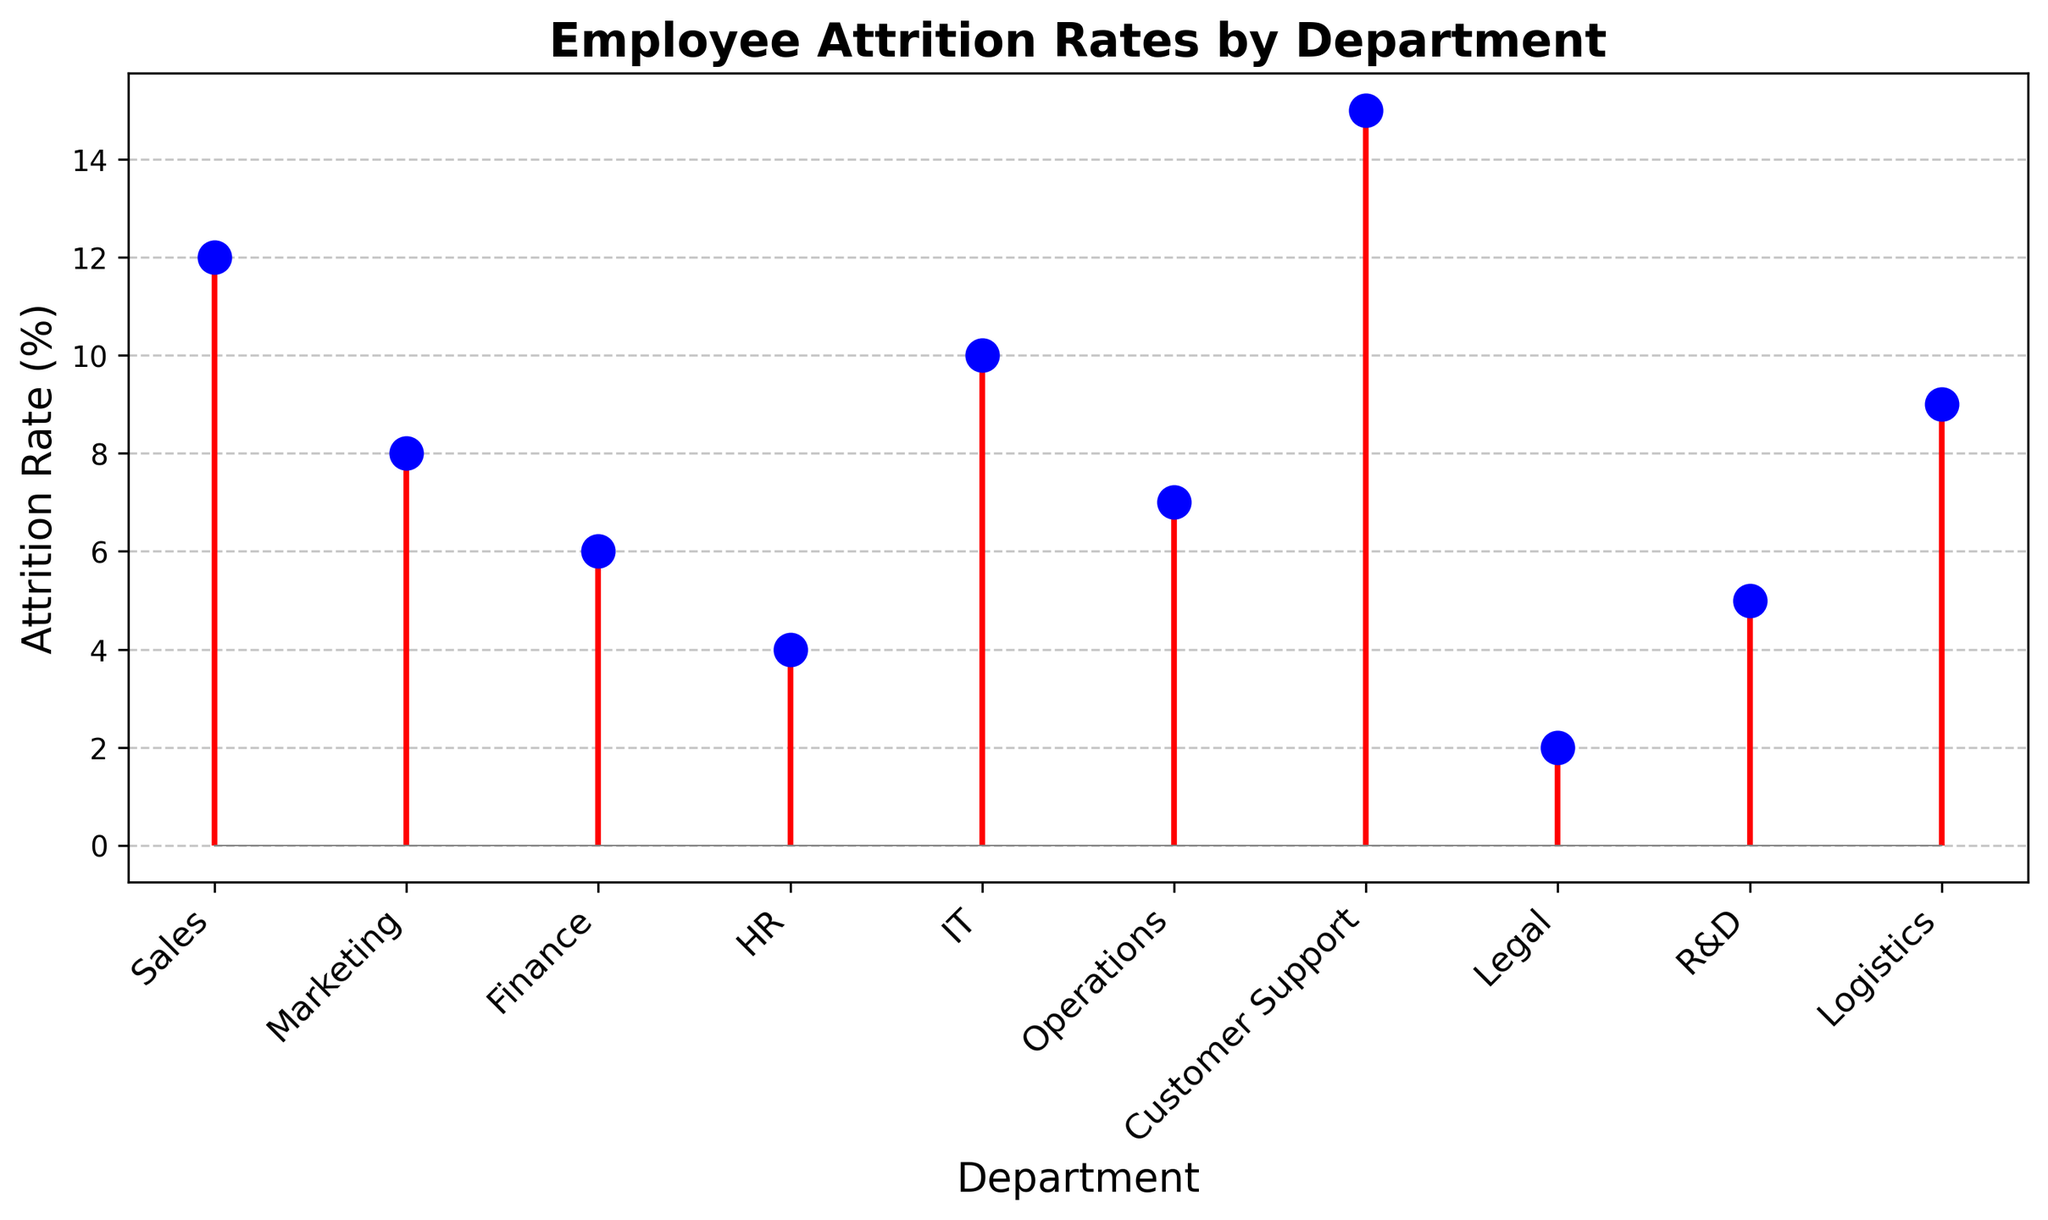What department has the highest attrition rate? By looking at the figure, identify the department with the tallest stem line, which is the blue line with the highest red line.
Answer: Customer Support Which department has an attrition rate lower than 5%? Locate the stems that do not reach the 5% mark on the y-axis. The Legal and HR departments have these shorter stems.
Answer: Legal, HR What's the difference in attrition rates between the Sales and IT departments? Identify the y-values for both the Sales and IT departments, which are 12% and 10% respectively. Subtract the IT attrition rate from the Sales attrition rate: 12 - 10 = 2.
Answer: 2% How many departments have an attrition rate greater than 8%? Count the number of stems that go above the 8% mark. The answer is four: Sales, IT, Customer Support, and Logistics.
Answer: 4 What's the median attrition rate of the departments? List all the attrition rates in ascending order: 2, 4, 5, 6, 7, 8, 9, 10, 12, 15. Since there are 10 values, the median is the average of the 5th and 6th values. (7+8)/2 = 7.5.
Answer: 7.5% Which department has the second lowest attrition rate? Arrange the attrition rates in ascending order: Legal (2), HR (4), R&D (5), and so on. The second department on the list is HR.
Answer: HR What is the average attrition rate of departments with rates lower than 10%? Identify the departments with rates under 10%: Legal (2), HR (4), R&D (5), Finance (6), Operations (7), and Marketing (8). Calculate the average: (2 + 4 + 5 +6 + 7 + 8)/6 ≈ 5.33.
Answer: 5.33% Compare the attrition rates between the Finance and Marketing departments. Which one is higher? Locate the y-values for both the Finance (6%) and Marketing (8%) departments. Marketing has a higher attrition rate.
Answer: Marketing Which department has a stem with the third tallest height? Rank the stems by their heights to find that the Sales, Customer Support, and then IT departments have the tallest stems in that order.
Answer: IT What is the combined attrition rate for the HR, Legal, and R&D departments? Sum the individual attrition rates for HR (4%), Legal (2%), and R&D (5%). Therefore, 4 + 2 + 5 = 11%.
Answer: 11% 